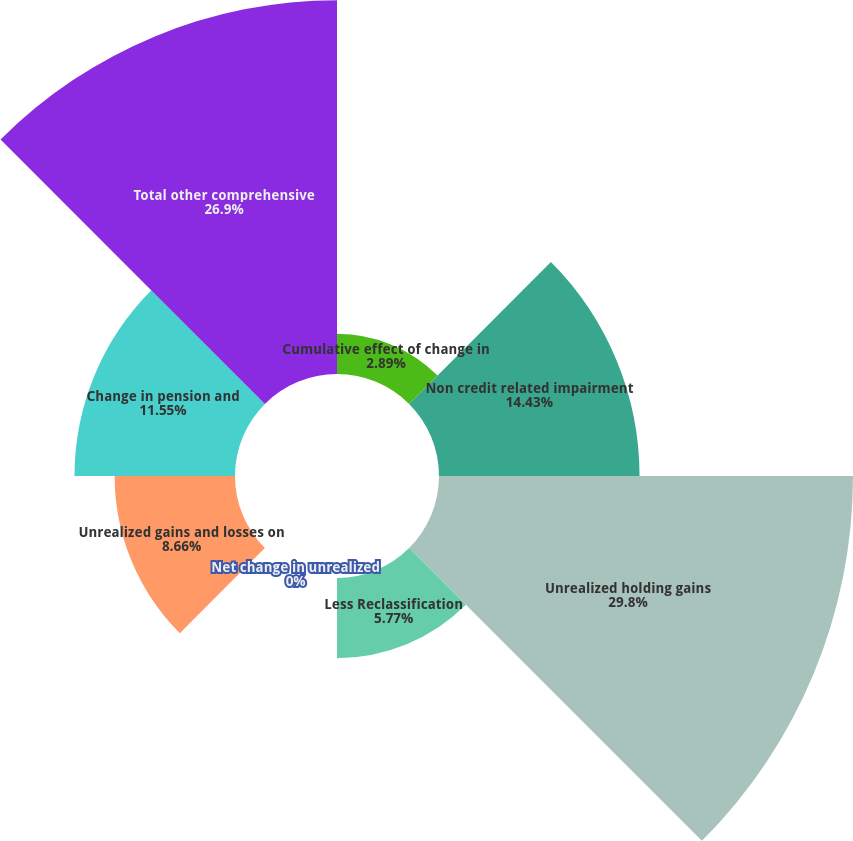<chart> <loc_0><loc_0><loc_500><loc_500><pie_chart><fcel>Cumulative effect of change in<fcel>Non credit related impairment<fcel>Unrealized holding gains<fcel>Less Reclassification<fcel>Net change in unrealized<fcel>Unrealized gains and losses on<fcel>Change in pension and<fcel>Total other comprehensive<nl><fcel>2.89%<fcel>14.43%<fcel>29.79%<fcel>5.77%<fcel>0.0%<fcel>8.66%<fcel>11.55%<fcel>26.9%<nl></chart> 